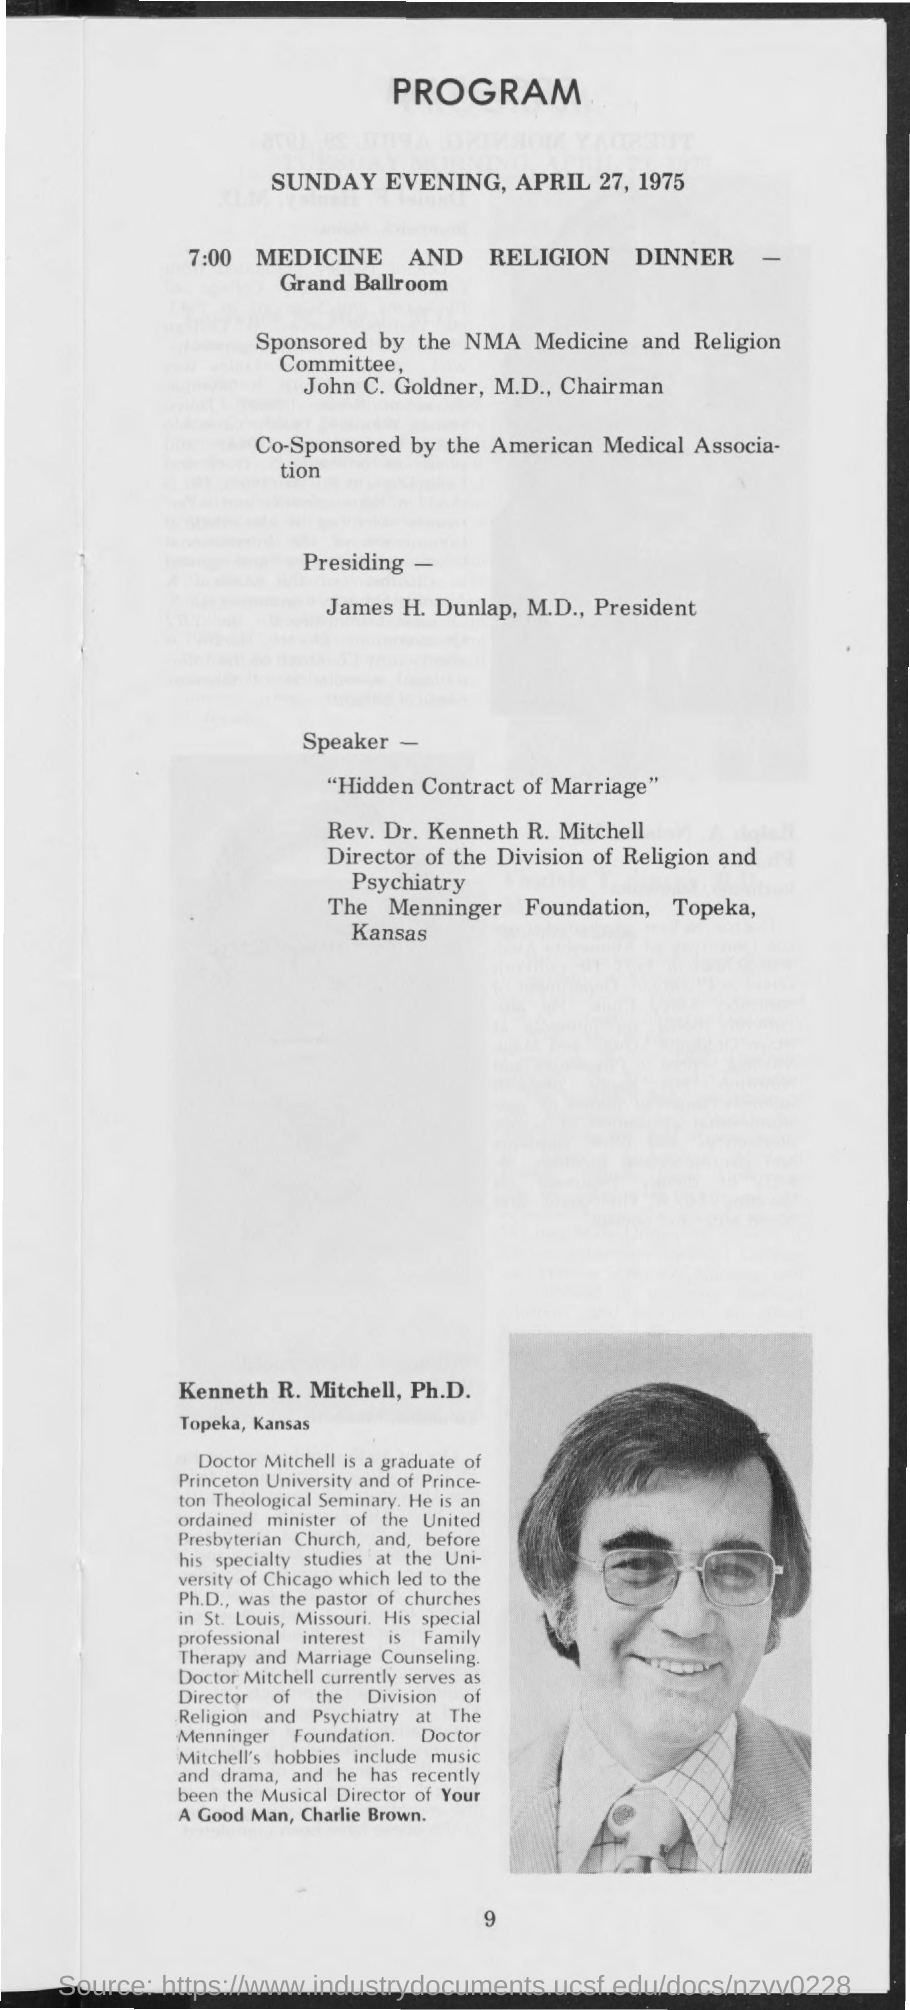Outline some significant characteristics in this image. The program will take place on Sunday evening, April 27, 1975. The medicine and religion dinner will take place at 7:00 PM. The American Medical Association is a co-sponsor of this event. The location of the Medicine and Religion Dinner is the GRAND BALLROOM. Rev. Dr. Kenneth R. Mitchell is the speaker for "Hidden Contract of Marriage." 